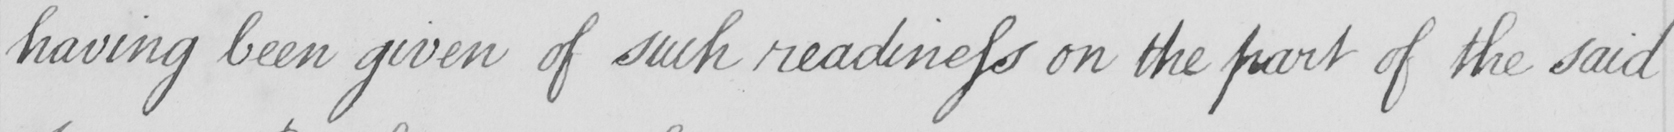What is written in this line of handwriting? having been given of such readiness on the part of the said 